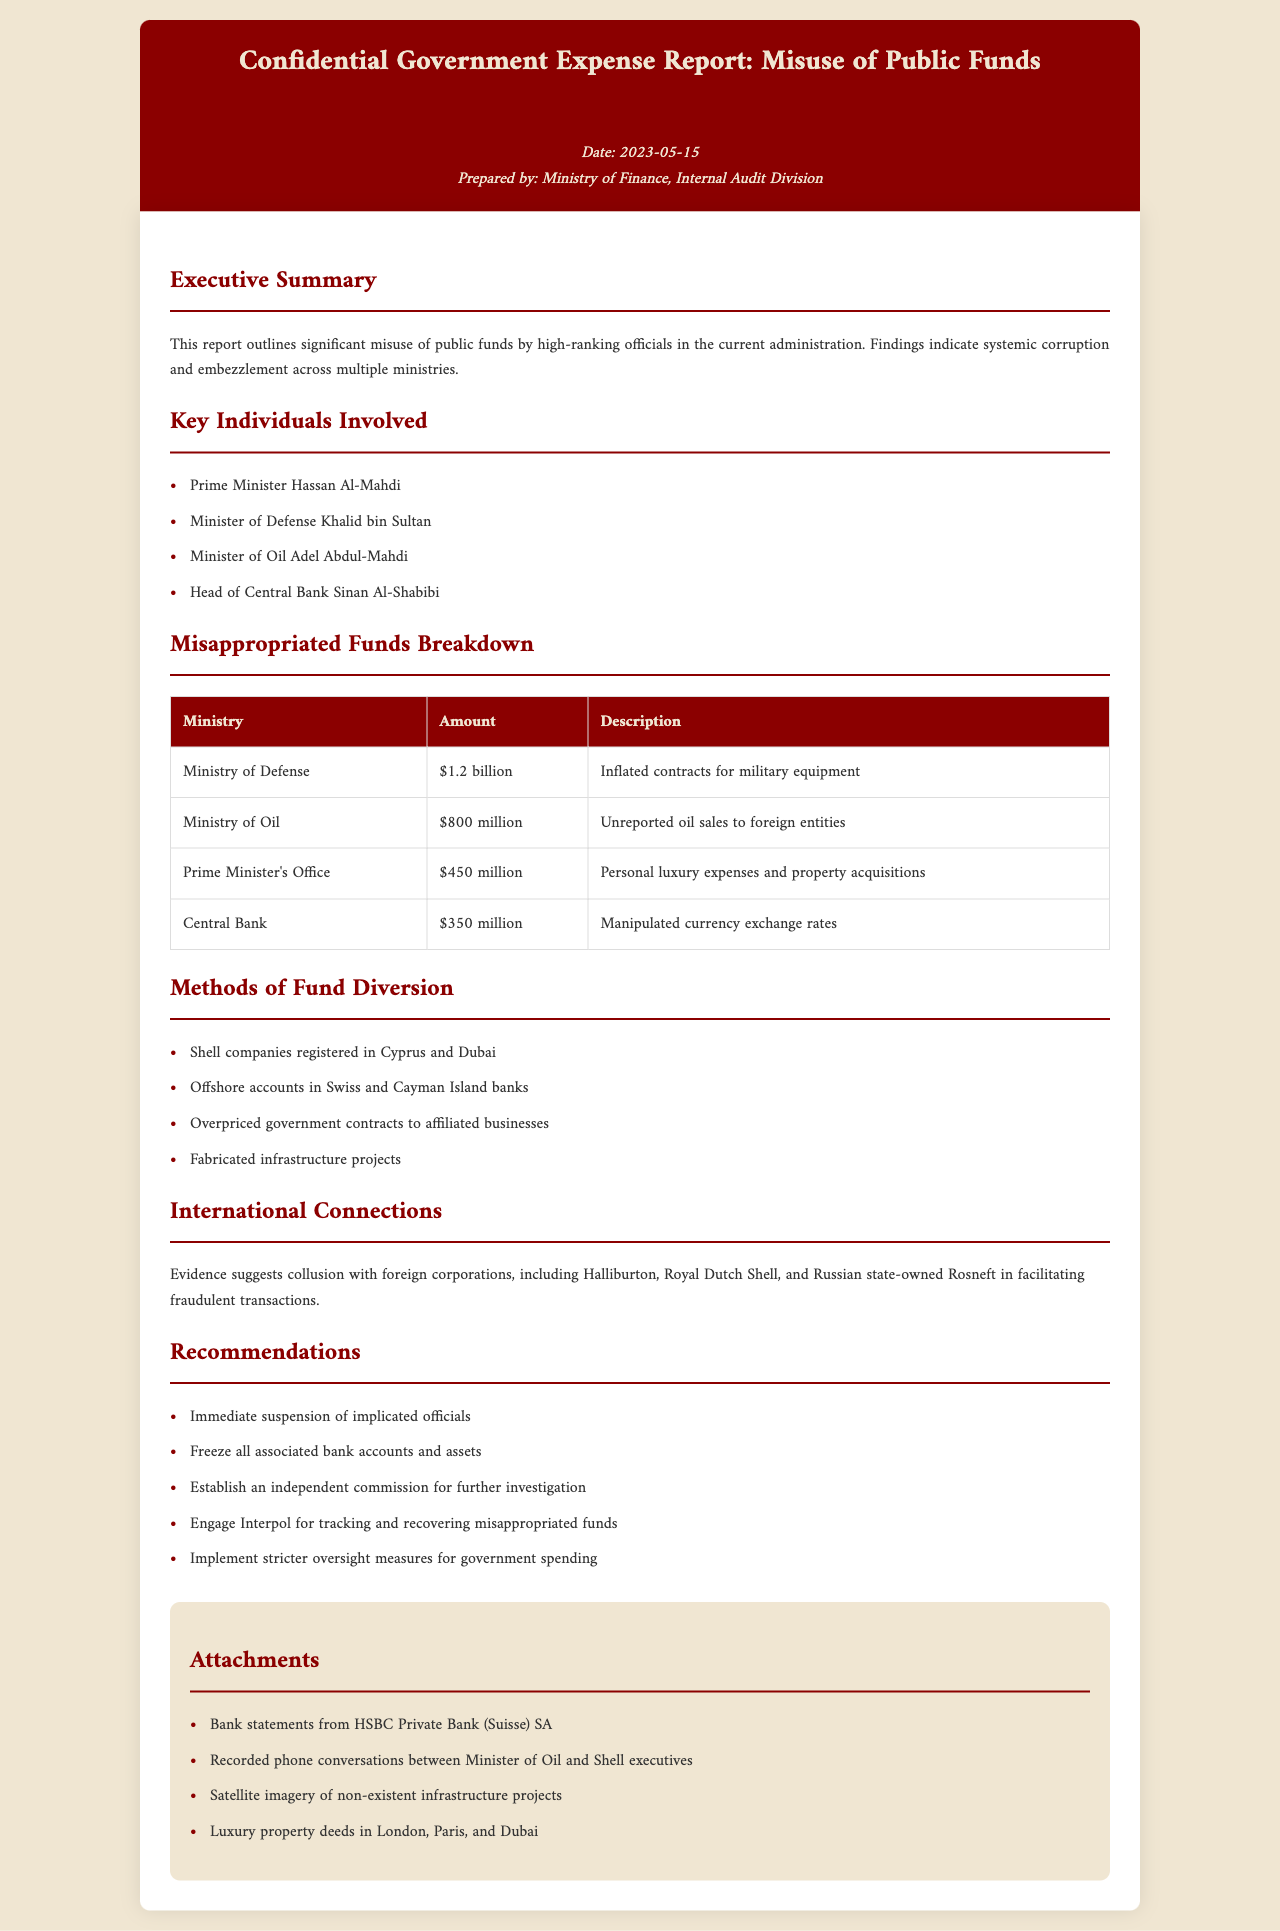what is the document title? The document title is presented at the top of the report.
Answer: Confidential Government Expense Report: Misuse of Public Funds who prepared the document? The preparation of the document is attributed to a specific division within the government.
Answer: Ministry of Finance, Internal Audit Division how much was misappropriated from the Ministry of Defense? The report provides a breakdown of misappropriated funds by ministry including specific amounts.
Answer: $1.2 billion who is listed as the Head of the Central Bank? The report names specific individuals involved in the misuse of funds.
Answer: Sinan Al-Shabibi what method was used for fund diversion related to government contracts? The document outlines methods used to divert funds and specific tactics employed.
Answer: Overpriced government contracts to affiliated businesses how much is associated with personal luxury expenses in the Prime Minister's Office? The report details specific misappropriated funds associated with various ministries.
Answer: $450 million what international corporation is mentioned in connection with the misuse of funds? The report lists corporations involved in fraudulent activities related to the misuse of funds.
Answer: Halliburton what is one of the recommendations provided in the report? The report offers specific recommendations for actions to address the misuse of funds.
Answer: Immediate suspension of implicated officials 